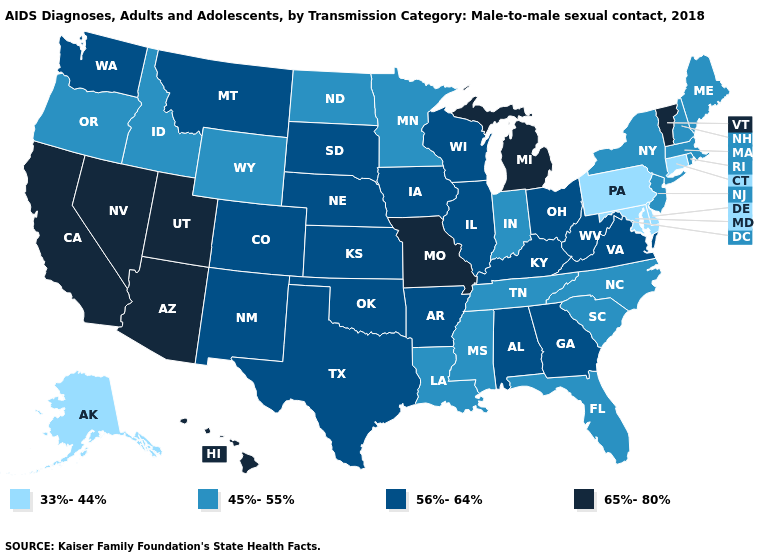Name the states that have a value in the range 33%-44%?
Keep it brief. Alaska, Connecticut, Delaware, Maryland, Pennsylvania. Among the states that border Louisiana , does Mississippi have the lowest value?
Concise answer only. Yes. Which states have the lowest value in the MidWest?
Quick response, please. Indiana, Minnesota, North Dakota. Is the legend a continuous bar?
Concise answer only. No. Name the states that have a value in the range 56%-64%?
Answer briefly. Alabama, Arkansas, Colorado, Georgia, Illinois, Iowa, Kansas, Kentucky, Montana, Nebraska, New Mexico, Ohio, Oklahoma, South Dakota, Texas, Virginia, Washington, West Virginia, Wisconsin. Which states have the lowest value in the South?
Answer briefly. Delaware, Maryland. Which states have the lowest value in the USA?
Be succinct. Alaska, Connecticut, Delaware, Maryland, Pennsylvania. Name the states that have a value in the range 33%-44%?
Give a very brief answer. Alaska, Connecticut, Delaware, Maryland, Pennsylvania. Does Delaware have the lowest value in the USA?
Answer briefly. Yes. What is the highest value in the USA?
Quick response, please. 65%-80%. Among the states that border Tennessee , does Georgia have the lowest value?
Write a very short answer. No. Among the states that border Oklahoma , does Missouri have the highest value?
Keep it brief. Yes. Name the states that have a value in the range 45%-55%?
Be succinct. Florida, Idaho, Indiana, Louisiana, Maine, Massachusetts, Minnesota, Mississippi, New Hampshire, New Jersey, New York, North Carolina, North Dakota, Oregon, Rhode Island, South Carolina, Tennessee, Wyoming. Name the states that have a value in the range 65%-80%?
Be succinct. Arizona, California, Hawaii, Michigan, Missouri, Nevada, Utah, Vermont. What is the value of Illinois?
Give a very brief answer. 56%-64%. 